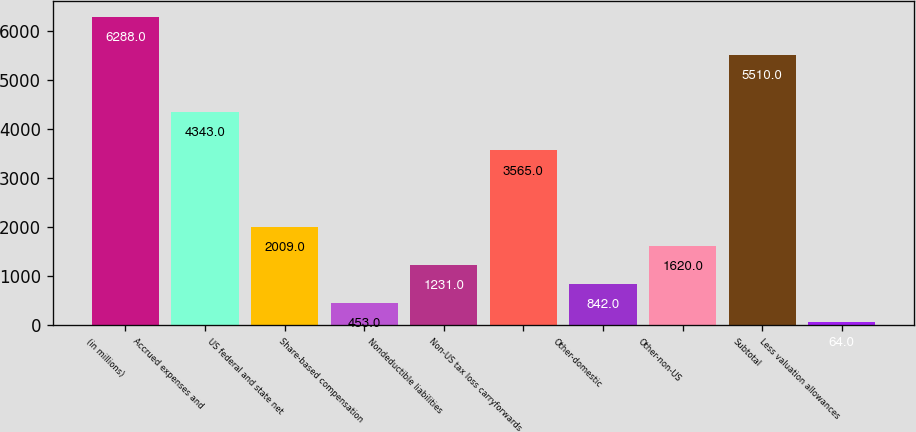<chart> <loc_0><loc_0><loc_500><loc_500><bar_chart><fcel>(in millions)<fcel>Accrued expenses and<fcel>US federal and state net<fcel>Share-based compensation<fcel>Nondeductible liabilities<fcel>Non-US tax loss carryforwards<fcel>Other-domestic<fcel>Other-non-US<fcel>Subtotal<fcel>Less valuation allowances<nl><fcel>6288<fcel>4343<fcel>2009<fcel>453<fcel>1231<fcel>3565<fcel>842<fcel>1620<fcel>5510<fcel>64<nl></chart> 